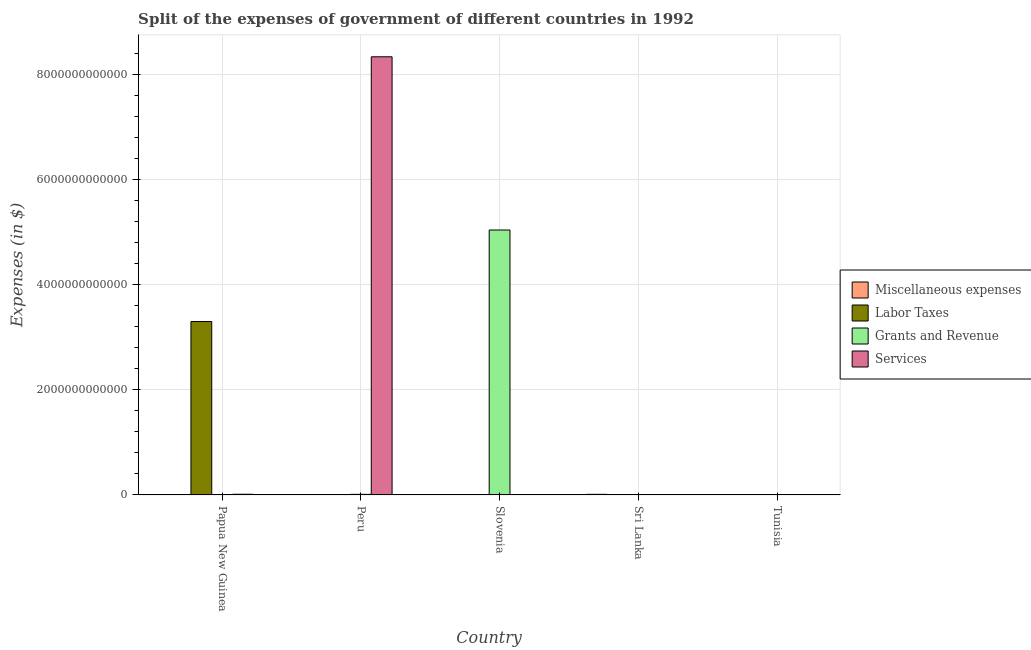How many different coloured bars are there?
Keep it short and to the point. 4. Are the number of bars per tick equal to the number of legend labels?
Your answer should be compact. Yes. How many bars are there on the 1st tick from the left?
Your answer should be compact. 4. What is the label of the 3rd group of bars from the left?
Provide a succinct answer. Slovenia. In how many cases, is the number of bars for a given country not equal to the number of legend labels?
Your answer should be compact. 0. What is the amount spent on labor taxes in Papua New Guinea?
Your answer should be compact. 3.30e+12. Across all countries, what is the maximum amount spent on miscellaneous expenses?
Offer a very short reply. 1.13e+1. Across all countries, what is the minimum amount spent on grants and revenue?
Give a very brief answer. 2.64e+08. In which country was the amount spent on labor taxes maximum?
Provide a short and direct response. Papua New Guinea. In which country was the amount spent on miscellaneous expenses minimum?
Keep it short and to the point. Papua New Guinea. What is the total amount spent on services in the graph?
Offer a terse response. 8.35e+12. What is the difference between the amount spent on grants and revenue in Slovenia and that in Tunisia?
Your answer should be very brief. 5.04e+12. What is the difference between the amount spent on miscellaneous expenses in Sri Lanka and the amount spent on services in Papua New Guinea?
Keep it short and to the point. -1.59e+09. What is the average amount spent on miscellaneous expenses per country?
Your response must be concise. 2.34e+09. What is the difference between the amount spent on labor taxes and amount spent on miscellaneous expenses in Tunisia?
Make the answer very short. 3.87e+09. In how many countries, is the amount spent on labor taxes greater than 4400000000000 $?
Your answer should be compact. 0. What is the ratio of the amount spent on labor taxes in Peru to that in Slovenia?
Keep it short and to the point. 0.54. Is the amount spent on labor taxes in Peru less than that in Sri Lanka?
Your answer should be very brief. Yes. What is the difference between the highest and the second highest amount spent on services?
Provide a succinct answer. 8.33e+12. What is the difference between the highest and the lowest amount spent on miscellaneous expenses?
Your response must be concise. 1.13e+1. What does the 2nd bar from the left in Sri Lanka represents?
Your response must be concise. Labor Taxes. What does the 2nd bar from the right in Papua New Guinea represents?
Make the answer very short. Grants and Revenue. Are all the bars in the graph horizontal?
Provide a succinct answer. No. How many countries are there in the graph?
Your answer should be very brief. 5. What is the difference between two consecutive major ticks on the Y-axis?
Your answer should be compact. 2.00e+12. Does the graph contain any zero values?
Give a very brief answer. No. What is the title of the graph?
Offer a terse response. Split of the expenses of government of different countries in 1992. Does "Gender equality" appear as one of the legend labels in the graph?
Your answer should be compact. No. What is the label or title of the Y-axis?
Offer a terse response. Expenses (in $). What is the Expenses (in $) of Miscellaneous expenses in Papua New Guinea?
Your answer should be compact. 4.48e+06. What is the Expenses (in $) in Labor Taxes in Papua New Guinea?
Your response must be concise. 3.30e+12. What is the Expenses (in $) of Grants and Revenue in Papua New Guinea?
Offer a very short reply. 4.17e+08. What is the Expenses (in $) in Services in Papua New Guinea?
Offer a very short reply. 1.29e+1. What is the Expenses (in $) of Miscellaneous expenses in Peru?
Provide a succinct answer. 1.22e+08. What is the Expenses (in $) of Grants and Revenue in Peru?
Ensure brevity in your answer.  1.10e+1. What is the Expenses (in $) of Services in Peru?
Offer a very short reply. 8.34e+12. What is the Expenses (in $) of Miscellaneous expenses in Slovenia?
Ensure brevity in your answer.  2.09e+07. What is the Expenses (in $) of Labor Taxes in Slovenia?
Offer a very short reply. 1.84e+06. What is the Expenses (in $) of Grants and Revenue in Slovenia?
Offer a terse response. 5.04e+12. What is the Expenses (in $) of Services in Slovenia?
Your response must be concise. 9.87e+08. What is the Expenses (in $) in Miscellaneous expenses in Sri Lanka?
Your answer should be very brief. 1.13e+1. What is the Expenses (in $) in Labor Taxes in Sri Lanka?
Your answer should be very brief. 4.20e+06. What is the Expenses (in $) in Grants and Revenue in Sri Lanka?
Your answer should be compact. 5.80e+08. What is the Expenses (in $) in Services in Sri Lanka?
Your answer should be very brief. 2.65e+08. What is the Expenses (in $) of Miscellaneous expenses in Tunisia?
Your answer should be compact. 2.81e+08. What is the Expenses (in $) in Labor Taxes in Tunisia?
Keep it short and to the point. 4.15e+09. What is the Expenses (in $) in Grants and Revenue in Tunisia?
Provide a succinct answer. 2.64e+08. What is the Expenses (in $) in Services in Tunisia?
Your answer should be very brief. 3.66e+08. Across all countries, what is the maximum Expenses (in $) of Miscellaneous expenses?
Make the answer very short. 1.13e+1. Across all countries, what is the maximum Expenses (in $) of Labor Taxes?
Provide a succinct answer. 3.30e+12. Across all countries, what is the maximum Expenses (in $) of Grants and Revenue?
Provide a succinct answer. 5.04e+12. Across all countries, what is the maximum Expenses (in $) of Services?
Keep it short and to the point. 8.34e+12. Across all countries, what is the minimum Expenses (in $) of Miscellaneous expenses?
Provide a short and direct response. 4.48e+06. Across all countries, what is the minimum Expenses (in $) in Grants and Revenue?
Give a very brief answer. 2.64e+08. Across all countries, what is the minimum Expenses (in $) of Services?
Offer a terse response. 2.65e+08. What is the total Expenses (in $) of Miscellaneous expenses in the graph?
Provide a short and direct response. 1.17e+1. What is the total Expenses (in $) of Labor Taxes in the graph?
Make the answer very short. 3.30e+12. What is the total Expenses (in $) in Grants and Revenue in the graph?
Provide a short and direct response. 5.05e+12. What is the total Expenses (in $) in Services in the graph?
Provide a succinct answer. 8.35e+12. What is the difference between the Expenses (in $) of Miscellaneous expenses in Papua New Guinea and that in Peru?
Keep it short and to the point. -1.18e+08. What is the difference between the Expenses (in $) of Labor Taxes in Papua New Guinea and that in Peru?
Give a very brief answer. 3.30e+12. What is the difference between the Expenses (in $) in Grants and Revenue in Papua New Guinea and that in Peru?
Your answer should be compact. -1.05e+1. What is the difference between the Expenses (in $) in Services in Papua New Guinea and that in Peru?
Ensure brevity in your answer.  -8.33e+12. What is the difference between the Expenses (in $) of Miscellaneous expenses in Papua New Guinea and that in Slovenia?
Provide a succinct answer. -1.64e+07. What is the difference between the Expenses (in $) of Labor Taxes in Papua New Guinea and that in Slovenia?
Provide a succinct answer. 3.30e+12. What is the difference between the Expenses (in $) in Grants and Revenue in Papua New Guinea and that in Slovenia?
Make the answer very short. -5.04e+12. What is the difference between the Expenses (in $) in Services in Papua New Guinea and that in Slovenia?
Ensure brevity in your answer.  1.19e+1. What is the difference between the Expenses (in $) in Miscellaneous expenses in Papua New Guinea and that in Sri Lanka?
Give a very brief answer. -1.13e+1. What is the difference between the Expenses (in $) in Labor Taxes in Papua New Guinea and that in Sri Lanka?
Provide a short and direct response. 3.30e+12. What is the difference between the Expenses (in $) of Grants and Revenue in Papua New Guinea and that in Sri Lanka?
Keep it short and to the point. -1.63e+08. What is the difference between the Expenses (in $) in Services in Papua New Guinea and that in Sri Lanka?
Your answer should be very brief. 1.26e+1. What is the difference between the Expenses (in $) of Miscellaneous expenses in Papua New Guinea and that in Tunisia?
Give a very brief answer. -2.77e+08. What is the difference between the Expenses (in $) of Labor Taxes in Papua New Guinea and that in Tunisia?
Ensure brevity in your answer.  3.30e+12. What is the difference between the Expenses (in $) of Grants and Revenue in Papua New Guinea and that in Tunisia?
Make the answer very short. 1.53e+08. What is the difference between the Expenses (in $) in Services in Papua New Guinea and that in Tunisia?
Make the answer very short. 1.25e+1. What is the difference between the Expenses (in $) of Miscellaneous expenses in Peru and that in Slovenia?
Keep it short and to the point. 1.01e+08. What is the difference between the Expenses (in $) in Labor Taxes in Peru and that in Slovenia?
Your response must be concise. -8.39e+05. What is the difference between the Expenses (in $) of Grants and Revenue in Peru and that in Slovenia?
Make the answer very short. -5.03e+12. What is the difference between the Expenses (in $) in Services in Peru and that in Slovenia?
Give a very brief answer. 8.34e+12. What is the difference between the Expenses (in $) in Miscellaneous expenses in Peru and that in Sri Lanka?
Offer a terse response. -1.12e+1. What is the difference between the Expenses (in $) in Labor Taxes in Peru and that in Sri Lanka?
Keep it short and to the point. -3.20e+06. What is the difference between the Expenses (in $) of Grants and Revenue in Peru and that in Sri Lanka?
Keep it short and to the point. 1.04e+1. What is the difference between the Expenses (in $) of Services in Peru and that in Sri Lanka?
Give a very brief answer. 8.34e+12. What is the difference between the Expenses (in $) of Miscellaneous expenses in Peru and that in Tunisia?
Provide a succinct answer. -1.59e+08. What is the difference between the Expenses (in $) of Labor Taxes in Peru and that in Tunisia?
Your answer should be very brief. -4.15e+09. What is the difference between the Expenses (in $) in Grants and Revenue in Peru and that in Tunisia?
Offer a very short reply. 1.07e+1. What is the difference between the Expenses (in $) in Services in Peru and that in Tunisia?
Keep it short and to the point. 8.34e+12. What is the difference between the Expenses (in $) of Miscellaneous expenses in Slovenia and that in Sri Lanka?
Ensure brevity in your answer.  -1.13e+1. What is the difference between the Expenses (in $) in Labor Taxes in Slovenia and that in Sri Lanka?
Offer a terse response. -2.36e+06. What is the difference between the Expenses (in $) of Grants and Revenue in Slovenia and that in Sri Lanka?
Your response must be concise. 5.04e+12. What is the difference between the Expenses (in $) of Services in Slovenia and that in Sri Lanka?
Offer a terse response. 7.22e+08. What is the difference between the Expenses (in $) in Miscellaneous expenses in Slovenia and that in Tunisia?
Offer a very short reply. -2.60e+08. What is the difference between the Expenses (in $) in Labor Taxes in Slovenia and that in Tunisia?
Provide a short and direct response. -4.15e+09. What is the difference between the Expenses (in $) in Grants and Revenue in Slovenia and that in Tunisia?
Offer a very short reply. 5.04e+12. What is the difference between the Expenses (in $) in Services in Slovenia and that in Tunisia?
Provide a short and direct response. 6.21e+08. What is the difference between the Expenses (in $) of Miscellaneous expenses in Sri Lanka and that in Tunisia?
Provide a short and direct response. 1.10e+1. What is the difference between the Expenses (in $) in Labor Taxes in Sri Lanka and that in Tunisia?
Provide a short and direct response. -4.15e+09. What is the difference between the Expenses (in $) of Grants and Revenue in Sri Lanka and that in Tunisia?
Offer a very short reply. 3.16e+08. What is the difference between the Expenses (in $) in Services in Sri Lanka and that in Tunisia?
Ensure brevity in your answer.  -1.01e+08. What is the difference between the Expenses (in $) in Miscellaneous expenses in Papua New Guinea and the Expenses (in $) in Labor Taxes in Peru?
Keep it short and to the point. 3.48e+06. What is the difference between the Expenses (in $) of Miscellaneous expenses in Papua New Guinea and the Expenses (in $) of Grants and Revenue in Peru?
Your answer should be compact. -1.10e+1. What is the difference between the Expenses (in $) in Miscellaneous expenses in Papua New Guinea and the Expenses (in $) in Services in Peru?
Give a very brief answer. -8.34e+12. What is the difference between the Expenses (in $) in Labor Taxes in Papua New Guinea and the Expenses (in $) in Grants and Revenue in Peru?
Ensure brevity in your answer.  3.29e+12. What is the difference between the Expenses (in $) in Labor Taxes in Papua New Guinea and the Expenses (in $) in Services in Peru?
Your answer should be very brief. -5.04e+12. What is the difference between the Expenses (in $) of Grants and Revenue in Papua New Guinea and the Expenses (in $) of Services in Peru?
Keep it short and to the point. -8.34e+12. What is the difference between the Expenses (in $) of Miscellaneous expenses in Papua New Guinea and the Expenses (in $) of Labor Taxes in Slovenia?
Your answer should be compact. 2.64e+06. What is the difference between the Expenses (in $) of Miscellaneous expenses in Papua New Guinea and the Expenses (in $) of Grants and Revenue in Slovenia?
Ensure brevity in your answer.  -5.04e+12. What is the difference between the Expenses (in $) of Miscellaneous expenses in Papua New Guinea and the Expenses (in $) of Services in Slovenia?
Your answer should be compact. -9.83e+08. What is the difference between the Expenses (in $) of Labor Taxes in Papua New Guinea and the Expenses (in $) of Grants and Revenue in Slovenia?
Provide a short and direct response. -1.74e+12. What is the difference between the Expenses (in $) in Labor Taxes in Papua New Guinea and the Expenses (in $) in Services in Slovenia?
Make the answer very short. 3.30e+12. What is the difference between the Expenses (in $) of Grants and Revenue in Papua New Guinea and the Expenses (in $) of Services in Slovenia?
Your answer should be compact. -5.70e+08. What is the difference between the Expenses (in $) of Miscellaneous expenses in Papua New Guinea and the Expenses (in $) of Labor Taxes in Sri Lanka?
Offer a terse response. 2.80e+05. What is the difference between the Expenses (in $) of Miscellaneous expenses in Papua New Guinea and the Expenses (in $) of Grants and Revenue in Sri Lanka?
Ensure brevity in your answer.  -5.76e+08. What is the difference between the Expenses (in $) of Miscellaneous expenses in Papua New Guinea and the Expenses (in $) of Services in Sri Lanka?
Ensure brevity in your answer.  -2.61e+08. What is the difference between the Expenses (in $) in Labor Taxes in Papua New Guinea and the Expenses (in $) in Grants and Revenue in Sri Lanka?
Make the answer very short. 3.30e+12. What is the difference between the Expenses (in $) in Labor Taxes in Papua New Guinea and the Expenses (in $) in Services in Sri Lanka?
Your answer should be compact. 3.30e+12. What is the difference between the Expenses (in $) in Grants and Revenue in Papua New Guinea and the Expenses (in $) in Services in Sri Lanka?
Ensure brevity in your answer.  1.52e+08. What is the difference between the Expenses (in $) of Miscellaneous expenses in Papua New Guinea and the Expenses (in $) of Labor Taxes in Tunisia?
Provide a short and direct response. -4.15e+09. What is the difference between the Expenses (in $) of Miscellaneous expenses in Papua New Guinea and the Expenses (in $) of Grants and Revenue in Tunisia?
Provide a succinct answer. -2.59e+08. What is the difference between the Expenses (in $) in Miscellaneous expenses in Papua New Guinea and the Expenses (in $) in Services in Tunisia?
Provide a short and direct response. -3.62e+08. What is the difference between the Expenses (in $) of Labor Taxes in Papua New Guinea and the Expenses (in $) of Grants and Revenue in Tunisia?
Your answer should be very brief. 3.30e+12. What is the difference between the Expenses (in $) in Labor Taxes in Papua New Guinea and the Expenses (in $) in Services in Tunisia?
Your answer should be very brief. 3.30e+12. What is the difference between the Expenses (in $) in Grants and Revenue in Papua New Guinea and the Expenses (in $) in Services in Tunisia?
Make the answer very short. 5.06e+07. What is the difference between the Expenses (in $) of Miscellaneous expenses in Peru and the Expenses (in $) of Labor Taxes in Slovenia?
Your answer should be very brief. 1.20e+08. What is the difference between the Expenses (in $) in Miscellaneous expenses in Peru and the Expenses (in $) in Grants and Revenue in Slovenia?
Your answer should be compact. -5.04e+12. What is the difference between the Expenses (in $) of Miscellaneous expenses in Peru and the Expenses (in $) of Services in Slovenia?
Provide a short and direct response. -8.65e+08. What is the difference between the Expenses (in $) in Labor Taxes in Peru and the Expenses (in $) in Grants and Revenue in Slovenia?
Give a very brief answer. -5.04e+12. What is the difference between the Expenses (in $) in Labor Taxes in Peru and the Expenses (in $) in Services in Slovenia?
Provide a short and direct response. -9.86e+08. What is the difference between the Expenses (in $) of Grants and Revenue in Peru and the Expenses (in $) of Services in Slovenia?
Your response must be concise. 9.97e+09. What is the difference between the Expenses (in $) in Miscellaneous expenses in Peru and the Expenses (in $) in Labor Taxes in Sri Lanka?
Keep it short and to the point. 1.18e+08. What is the difference between the Expenses (in $) in Miscellaneous expenses in Peru and the Expenses (in $) in Grants and Revenue in Sri Lanka?
Your answer should be very brief. -4.58e+08. What is the difference between the Expenses (in $) in Miscellaneous expenses in Peru and the Expenses (in $) in Services in Sri Lanka?
Give a very brief answer. -1.43e+08. What is the difference between the Expenses (in $) in Labor Taxes in Peru and the Expenses (in $) in Grants and Revenue in Sri Lanka?
Your response must be concise. -5.79e+08. What is the difference between the Expenses (in $) in Labor Taxes in Peru and the Expenses (in $) in Services in Sri Lanka?
Offer a very short reply. -2.64e+08. What is the difference between the Expenses (in $) of Grants and Revenue in Peru and the Expenses (in $) of Services in Sri Lanka?
Keep it short and to the point. 1.07e+1. What is the difference between the Expenses (in $) of Miscellaneous expenses in Peru and the Expenses (in $) of Labor Taxes in Tunisia?
Offer a terse response. -4.03e+09. What is the difference between the Expenses (in $) of Miscellaneous expenses in Peru and the Expenses (in $) of Grants and Revenue in Tunisia?
Keep it short and to the point. -1.42e+08. What is the difference between the Expenses (in $) of Miscellaneous expenses in Peru and the Expenses (in $) of Services in Tunisia?
Give a very brief answer. -2.44e+08. What is the difference between the Expenses (in $) in Labor Taxes in Peru and the Expenses (in $) in Grants and Revenue in Tunisia?
Give a very brief answer. -2.63e+08. What is the difference between the Expenses (in $) of Labor Taxes in Peru and the Expenses (in $) of Services in Tunisia?
Give a very brief answer. -3.65e+08. What is the difference between the Expenses (in $) of Grants and Revenue in Peru and the Expenses (in $) of Services in Tunisia?
Keep it short and to the point. 1.06e+1. What is the difference between the Expenses (in $) of Miscellaneous expenses in Slovenia and the Expenses (in $) of Labor Taxes in Sri Lanka?
Your answer should be very brief. 1.67e+07. What is the difference between the Expenses (in $) in Miscellaneous expenses in Slovenia and the Expenses (in $) in Grants and Revenue in Sri Lanka?
Provide a short and direct response. -5.59e+08. What is the difference between the Expenses (in $) of Miscellaneous expenses in Slovenia and the Expenses (in $) of Services in Sri Lanka?
Your answer should be very brief. -2.44e+08. What is the difference between the Expenses (in $) of Labor Taxes in Slovenia and the Expenses (in $) of Grants and Revenue in Sri Lanka?
Give a very brief answer. -5.78e+08. What is the difference between the Expenses (in $) of Labor Taxes in Slovenia and the Expenses (in $) of Services in Sri Lanka?
Your answer should be very brief. -2.63e+08. What is the difference between the Expenses (in $) in Grants and Revenue in Slovenia and the Expenses (in $) in Services in Sri Lanka?
Your answer should be very brief. 5.04e+12. What is the difference between the Expenses (in $) of Miscellaneous expenses in Slovenia and the Expenses (in $) of Labor Taxes in Tunisia?
Offer a very short reply. -4.13e+09. What is the difference between the Expenses (in $) of Miscellaneous expenses in Slovenia and the Expenses (in $) of Grants and Revenue in Tunisia?
Offer a very short reply. -2.43e+08. What is the difference between the Expenses (in $) of Miscellaneous expenses in Slovenia and the Expenses (in $) of Services in Tunisia?
Ensure brevity in your answer.  -3.46e+08. What is the difference between the Expenses (in $) of Labor Taxes in Slovenia and the Expenses (in $) of Grants and Revenue in Tunisia?
Your answer should be compact. -2.62e+08. What is the difference between the Expenses (in $) of Labor Taxes in Slovenia and the Expenses (in $) of Services in Tunisia?
Provide a succinct answer. -3.65e+08. What is the difference between the Expenses (in $) in Grants and Revenue in Slovenia and the Expenses (in $) in Services in Tunisia?
Keep it short and to the point. 5.04e+12. What is the difference between the Expenses (in $) of Miscellaneous expenses in Sri Lanka and the Expenses (in $) of Labor Taxes in Tunisia?
Your answer should be compact. 7.12e+09. What is the difference between the Expenses (in $) of Miscellaneous expenses in Sri Lanka and the Expenses (in $) of Grants and Revenue in Tunisia?
Offer a terse response. 1.10e+1. What is the difference between the Expenses (in $) of Miscellaneous expenses in Sri Lanka and the Expenses (in $) of Services in Tunisia?
Your answer should be compact. 1.09e+1. What is the difference between the Expenses (in $) of Labor Taxes in Sri Lanka and the Expenses (in $) of Grants and Revenue in Tunisia?
Give a very brief answer. -2.59e+08. What is the difference between the Expenses (in $) in Labor Taxes in Sri Lanka and the Expenses (in $) in Services in Tunisia?
Your answer should be very brief. -3.62e+08. What is the difference between the Expenses (in $) of Grants and Revenue in Sri Lanka and the Expenses (in $) of Services in Tunisia?
Give a very brief answer. 2.14e+08. What is the average Expenses (in $) in Miscellaneous expenses per country?
Provide a short and direct response. 2.34e+09. What is the average Expenses (in $) of Labor Taxes per country?
Ensure brevity in your answer.  6.61e+11. What is the average Expenses (in $) in Grants and Revenue per country?
Provide a succinct answer. 1.01e+12. What is the average Expenses (in $) of Services per country?
Your answer should be very brief. 1.67e+12. What is the difference between the Expenses (in $) in Miscellaneous expenses and Expenses (in $) in Labor Taxes in Papua New Guinea?
Keep it short and to the point. -3.30e+12. What is the difference between the Expenses (in $) of Miscellaneous expenses and Expenses (in $) of Grants and Revenue in Papua New Guinea?
Offer a very short reply. -4.12e+08. What is the difference between the Expenses (in $) of Miscellaneous expenses and Expenses (in $) of Services in Papua New Guinea?
Your response must be concise. -1.29e+1. What is the difference between the Expenses (in $) of Labor Taxes and Expenses (in $) of Grants and Revenue in Papua New Guinea?
Ensure brevity in your answer.  3.30e+12. What is the difference between the Expenses (in $) of Labor Taxes and Expenses (in $) of Services in Papua New Guinea?
Provide a succinct answer. 3.29e+12. What is the difference between the Expenses (in $) of Grants and Revenue and Expenses (in $) of Services in Papua New Guinea?
Provide a succinct answer. -1.24e+1. What is the difference between the Expenses (in $) of Miscellaneous expenses and Expenses (in $) of Labor Taxes in Peru?
Provide a succinct answer. 1.21e+08. What is the difference between the Expenses (in $) of Miscellaneous expenses and Expenses (in $) of Grants and Revenue in Peru?
Offer a terse response. -1.08e+1. What is the difference between the Expenses (in $) in Miscellaneous expenses and Expenses (in $) in Services in Peru?
Your response must be concise. -8.34e+12. What is the difference between the Expenses (in $) of Labor Taxes and Expenses (in $) of Grants and Revenue in Peru?
Offer a very short reply. -1.10e+1. What is the difference between the Expenses (in $) in Labor Taxes and Expenses (in $) in Services in Peru?
Ensure brevity in your answer.  -8.34e+12. What is the difference between the Expenses (in $) in Grants and Revenue and Expenses (in $) in Services in Peru?
Provide a succinct answer. -8.33e+12. What is the difference between the Expenses (in $) in Miscellaneous expenses and Expenses (in $) in Labor Taxes in Slovenia?
Ensure brevity in your answer.  1.90e+07. What is the difference between the Expenses (in $) in Miscellaneous expenses and Expenses (in $) in Grants and Revenue in Slovenia?
Give a very brief answer. -5.04e+12. What is the difference between the Expenses (in $) of Miscellaneous expenses and Expenses (in $) of Services in Slovenia?
Keep it short and to the point. -9.66e+08. What is the difference between the Expenses (in $) of Labor Taxes and Expenses (in $) of Grants and Revenue in Slovenia?
Make the answer very short. -5.04e+12. What is the difference between the Expenses (in $) of Labor Taxes and Expenses (in $) of Services in Slovenia?
Offer a very short reply. -9.85e+08. What is the difference between the Expenses (in $) in Grants and Revenue and Expenses (in $) in Services in Slovenia?
Offer a terse response. 5.04e+12. What is the difference between the Expenses (in $) of Miscellaneous expenses and Expenses (in $) of Labor Taxes in Sri Lanka?
Your answer should be compact. 1.13e+1. What is the difference between the Expenses (in $) in Miscellaneous expenses and Expenses (in $) in Grants and Revenue in Sri Lanka?
Your answer should be compact. 1.07e+1. What is the difference between the Expenses (in $) in Miscellaneous expenses and Expenses (in $) in Services in Sri Lanka?
Your answer should be very brief. 1.10e+1. What is the difference between the Expenses (in $) of Labor Taxes and Expenses (in $) of Grants and Revenue in Sri Lanka?
Your response must be concise. -5.76e+08. What is the difference between the Expenses (in $) in Labor Taxes and Expenses (in $) in Services in Sri Lanka?
Ensure brevity in your answer.  -2.61e+08. What is the difference between the Expenses (in $) of Grants and Revenue and Expenses (in $) of Services in Sri Lanka?
Keep it short and to the point. 3.15e+08. What is the difference between the Expenses (in $) of Miscellaneous expenses and Expenses (in $) of Labor Taxes in Tunisia?
Offer a very short reply. -3.87e+09. What is the difference between the Expenses (in $) in Miscellaneous expenses and Expenses (in $) in Grants and Revenue in Tunisia?
Keep it short and to the point. 1.76e+07. What is the difference between the Expenses (in $) in Miscellaneous expenses and Expenses (in $) in Services in Tunisia?
Your answer should be compact. -8.52e+07. What is the difference between the Expenses (in $) in Labor Taxes and Expenses (in $) in Grants and Revenue in Tunisia?
Provide a succinct answer. 3.89e+09. What is the difference between the Expenses (in $) of Labor Taxes and Expenses (in $) of Services in Tunisia?
Ensure brevity in your answer.  3.79e+09. What is the difference between the Expenses (in $) of Grants and Revenue and Expenses (in $) of Services in Tunisia?
Offer a very short reply. -1.03e+08. What is the ratio of the Expenses (in $) in Miscellaneous expenses in Papua New Guinea to that in Peru?
Provide a short and direct response. 0.04. What is the ratio of the Expenses (in $) in Labor Taxes in Papua New Guinea to that in Peru?
Make the answer very short. 3.30e+06. What is the ratio of the Expenses (in $) in Grants and Revenue in Papua New Guinea to that in Peru?
Your answer should be very brief. 0.04. What is the ratio of the Expenses (in $) in Services in Papua New Guinea to that in Peru?
Your answer should be very brief. 0. What is the ratio of the Expenses (in $) of Miscellaneous expenses in Papua New Guinea to that in Slovenia?
Your answer should be very brief. 0.21. What is the ratio of the Expenses (in $) of Labor Taxes in Papua New Guinea to that in Slovenia?
Offer a very short reply. 1.79e+06. What is the ratio of the Expenses (in $) of Grants and Revenue in Papua New Guinea to that in Slovenia?
Offer a very short reply. 0. What is the ratio of the Expenses (in $) of Services in Papua New Guinea to that in Slovenia?
Make the answer very short. 13.03. What is the ratio of the Expenses (in $) of Miscellaneous expenses in Papua New Guinea to that in Sri Lanka?
Offer a terse response. 0. What is the ratio of the Expenses (in $) of Labor Taxes in Papua New Guinea to that in Sri Lanka?
Offer a terse response. 7.86e+05. What is the ratio of the Expenses (in $) of Grants and Revenue in Papua New Guinea to that in Sri Lanka?
Your answer should be very brief. 0.72. What is the ratio of the Expenses (in $) of Services in Papua New Guinea to that in Sri Lanka?
Ensure brevity in your answer.  48.53. What is the ratio of the Expenses (in $) in Miscellaneous expenses in Papua New Guinea to that in Tunisia?
Make the answer very short. 0.02. What is the ratio of the Expenses (in $) of Labor Taxes in Papua New Guinea to that in Tunisia?
Your answer should be very brief. 794.61. What is the ratio of the Expenses (in $) in Grants and Revenue in Papua New Guinea to that in Tunisia?
Make the answer very short. 1.58. What is the ratio of the Expenses (in $) in Services in Papua New Guinea to that in Tunisia?
Provide a succinct answer. 35.11. What is the ratio of the Expenses (in $) in Miscellaneous expenses in Peru to that in Slovenia?
Ensure brevity in your answer.  5.85. What is the ratio of the Expenses (in $) in Labor Taxes in Peru to that in Slovenia?
Your answer should be compact. 0.54. What is the ratio of the Expenses (in $) in Grants and Revenue in Peru to that in Slovenia?
Ensure brevity in your answer.  0. What is the ratio of the Expenses (in $) in Services in Peru to that in Slovenia?
Keep it short and to the point. 8448.83. What is the ratio of the Expenses (in $) of Miscellaneous expenses in Peru to that in Sri Lanka?
Ensure brevity in your answer.  0.01. What is the ratio of the Expenses (in $) of Labor Taxes in Peru to that in Sri Lanka?
Your answer should be very brief. 0.24. What is the ratio of the Expenses (in $) of Grants and Revenue in Peru to that in Sri Lanka?
Give a very brief answer. 18.89. What is the ratio of the Expenses (in $) of Services in Peru to that in Sri Lanka?
Keep it short and to the point. 3.15e+04. What is the ratio of the Expenses (in $) in Miscellaneous expenses in Peru to that in Tunisia?
Keep it short and to the point. 0.43. What is the ratio of the Expenses (in $) in Grants and Revenue in Peru to that in Tunisia?
Ensure brevity in your answer.  41.57. What is the ratio of the Expenses (in $) in Services in Peru to that in Tunisia?
Make the answer very short. 2.28e+04. What is the ratio of the Expenses (in $) in Miscellaneous expenses in Slovenia to that in Sri Lanka?
Keep it short and to the point. 0. What is the ratio of the Expenses (in $) in Labor Taxes in Slovenia to that in Sri Lanka?
Keep it short and to the point. 0.44. What is the ratio of the Expenses (in $) of Grants and Revenue in Slovenia to that in Sri Lanka?
Ensure brevity in your answer.  8693.1. What is the ratio of the Expenses (in $) in Services in Slovenia to that in Sri Lanka?
Keep it short and to the point. 3.72. What is the ratio of the Expenses (in $) of Miscellaneous expenses in Slovenia to that in Tunisia?
Keep it short and to the point. 0.07. What is the ratio of the Expenses (in $) in Grants and Revenue in Slovenia to that in Tunisia?
Make the answer very short. 1.91e+04. What is the ratio of the Expenses (in $) of Services in Slovenia to that in Tunisia?
Provide a succinct answer. 2.69. What is the ratio of the Expenses (in $) of Miscellaneous expenses in Sri Lanka to that in Tunisia?
Make the answer very short. 40.09. What is the ratio of the Expenses (in $) in Grants and Revenue in Sri Lanka to that in Tunisia?
Keep it short and to the point. 2.2. What is the ratio of the Expenses (in $) of Services in Sri Lanka to that in Tunisia?
Your answer should be very brief. 0.72. What is the difference between the highest and the second highest Expenses (in $) in Miscellaneous expenses?
Give a very brief answer. 1.10e+1. What is the difference between the highest and the second highest Expenses (in $) in Labor Taxes?
Offer a very short reply. 3.30e+12. What is the difference between the highest and the second highest Expenses (in $) in Grants and Revenue?
Make the answer very short. 5.03e+12. What is the difference between the highest and the second highest Expenses (in $) in Services?
Offer a very short reply. 8.33e+12. What is the difference between the highest and the lowest Expenses (in $) in Miscellaneous expenses?
Ensure brevity in your answer.  1.13e+1. What is the difference between the highest and the lowest Expenses (in $) in Labor Taxes?
Provide a succinct answer. 3.30e+12. What is the difference between the highest and the lowest Expenses (in $) in Grants and Revenue?
Make the answer very short. 5.04e+12. What is the difference between the highest and the lowest Expenses (in $) in Services?
Provide a short and direct response. 8.34e+12. 